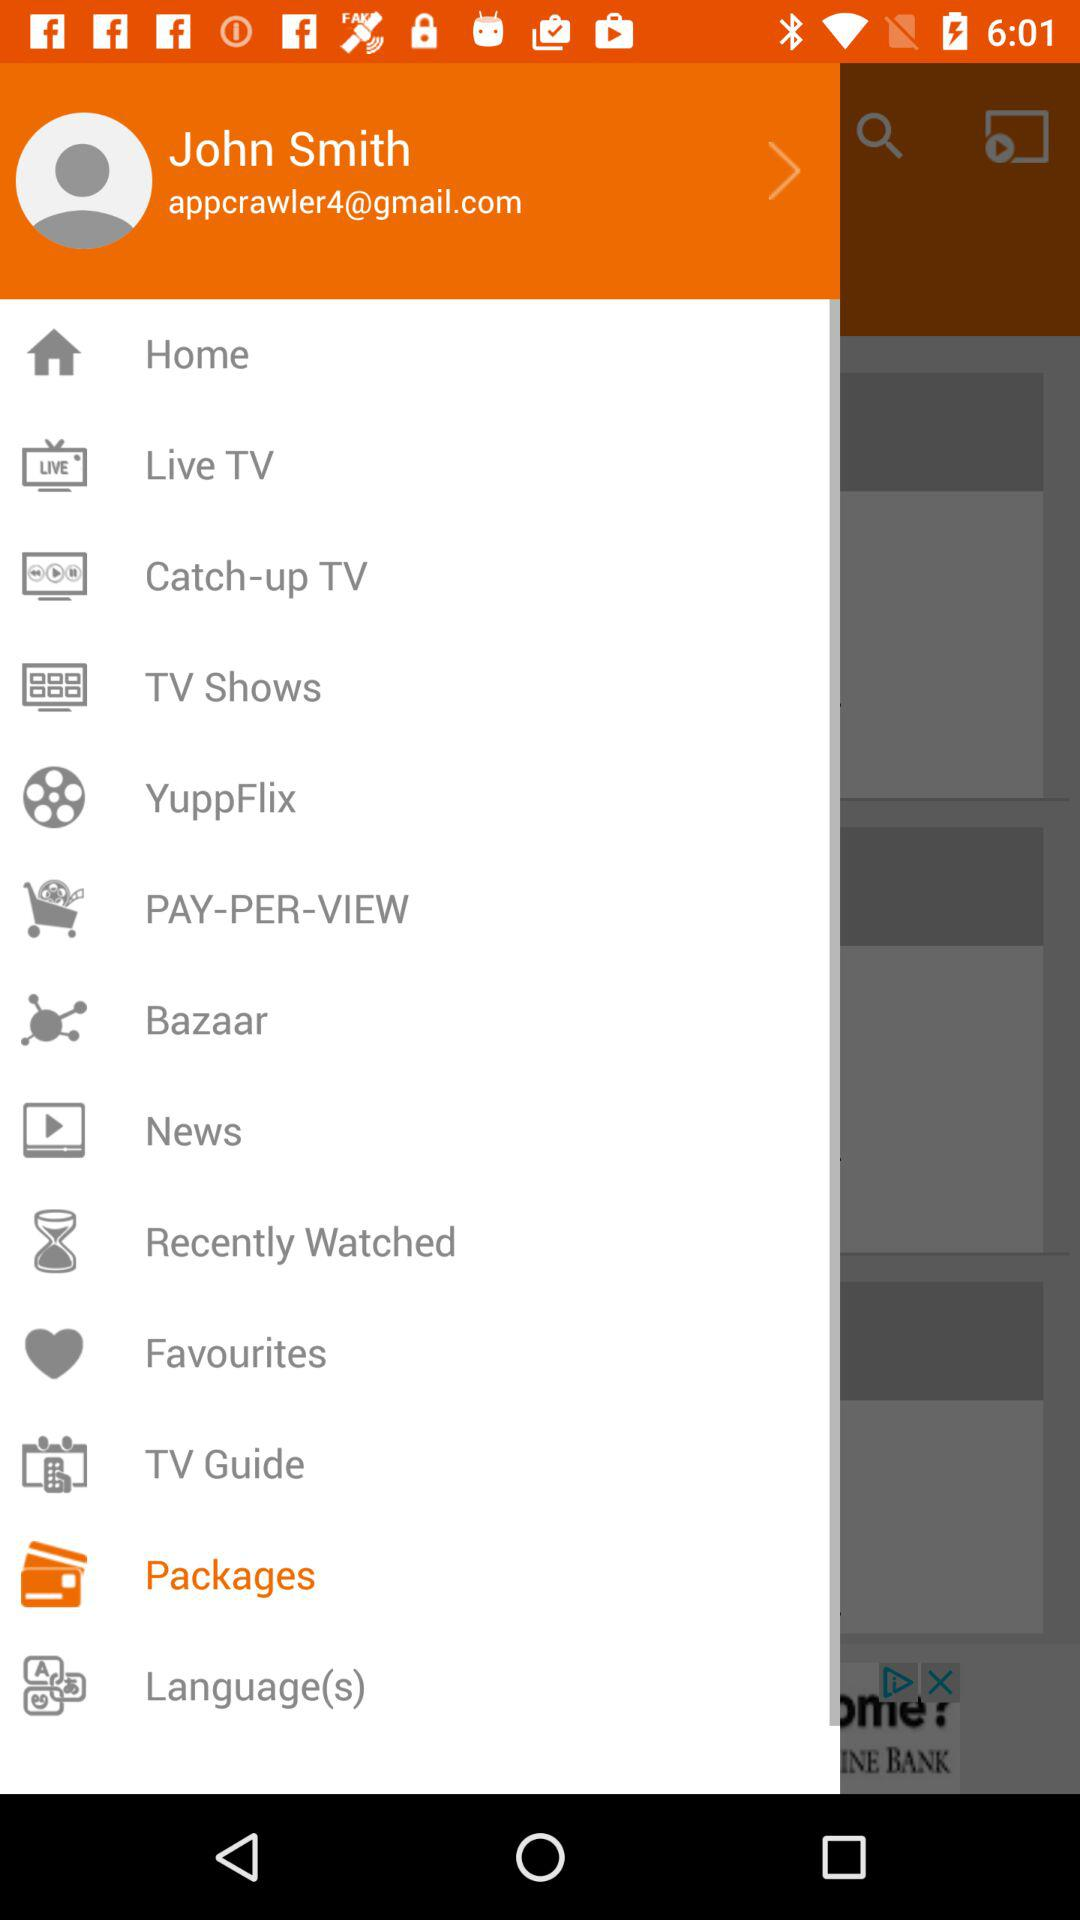What's the user profile name? The user profile name is John Smith. 